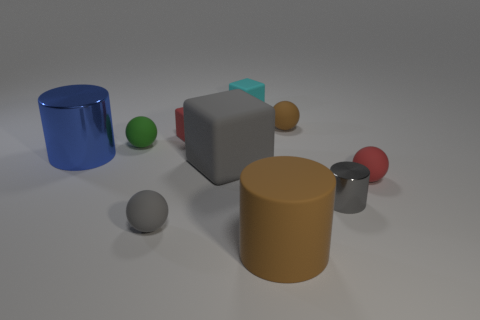Do the shiny thing to the left of the tiny green sphere and the red object to the right of the tiny gray shiny cylinder have the same size?
Your answer should be compact. No. The red cube that is made of the same material as the small red sphere is what size?
Your answer should be very brief. Small. What number of tiny matte things are both behind the tiny metal cylinder and left of the red sphere?
Provide a succinct answer. 4. What number of things are tiny gray metal things or tiny gray objects that are on the left side of the tiny cyan rubber thing?
Make the answer very short. 2. What shape is the tiny object that is the same color as the tiny metallic cylinder?
Your answer should be compact. Sphere. What is the color of the large object that is right of the cyan matte object?
Your answer should be compact. Brown. What number of objects are small rubber things that are in front of the blue cylinder or tiny brown matte things?
Keep it short and to the point. 3. There is a shiny thing that is the same size as the red rubber sphere; what color is it?
Give a very brief answer. Gray. Are there more tiny matte cubes in front of the blue metallic cylinder than tiny brown matte objects?
Ensure brevity in your answer.  No. What is the material of the cylinder that is to the left of the tiny gray cylinder and in front of the large gray rubber object?
Give a very brief answer. Rubber. 